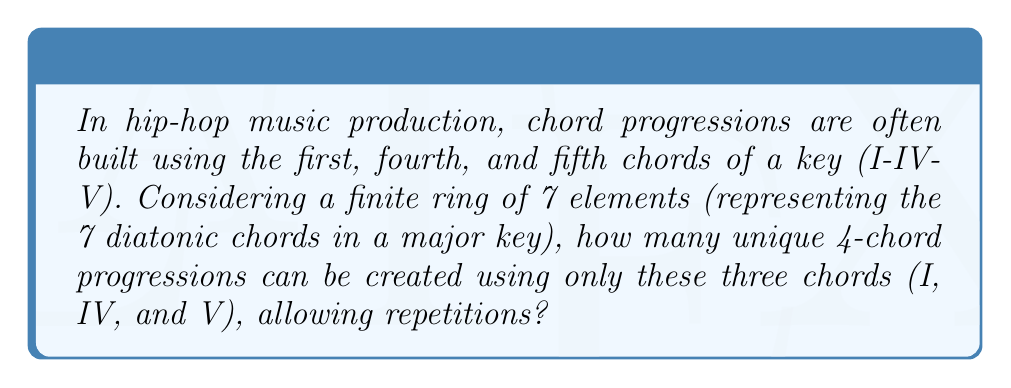Give your solution to this math problem. Let's approach this step-by-step:

1) First, we need to understand that we're working with a finite ring of 7 elements, representing the 7 diatonic chords in a major key. However, we're only using 3 of these elements: I, IV, and V.

2) We can represent this as a mapping from the set $\{1, 2, 3, 4\}$ (the four positions in our progression) to the set $\{I, IV, V\}$ (the three chords we're using).

3) This is equivalent to finding the number of functions from a set of size 4 to a set of size 3, where repetitions are allowed.

4) In ring theory, this is related to the concept of homomorphisms between finite rings.

5) The number of such functions is given by the formula:

   $$ n^m $$

   Where $n$ is the size of the codomain (the set we're mapping to) and $m$ is the size of the domain (the set we're mapping from).

6) In this case:
   $n = 3$ (the number of chords we're using)
   $m = 4$ (the number of positions in our progression)

7) Therefore, the number of possible progressions is:

   $$ 3^4 = 81 $$

This means there are 81 unique ways to arrange these three chords into a 4-chord progression.
Answer: $81$ unique 4-chord progressions 